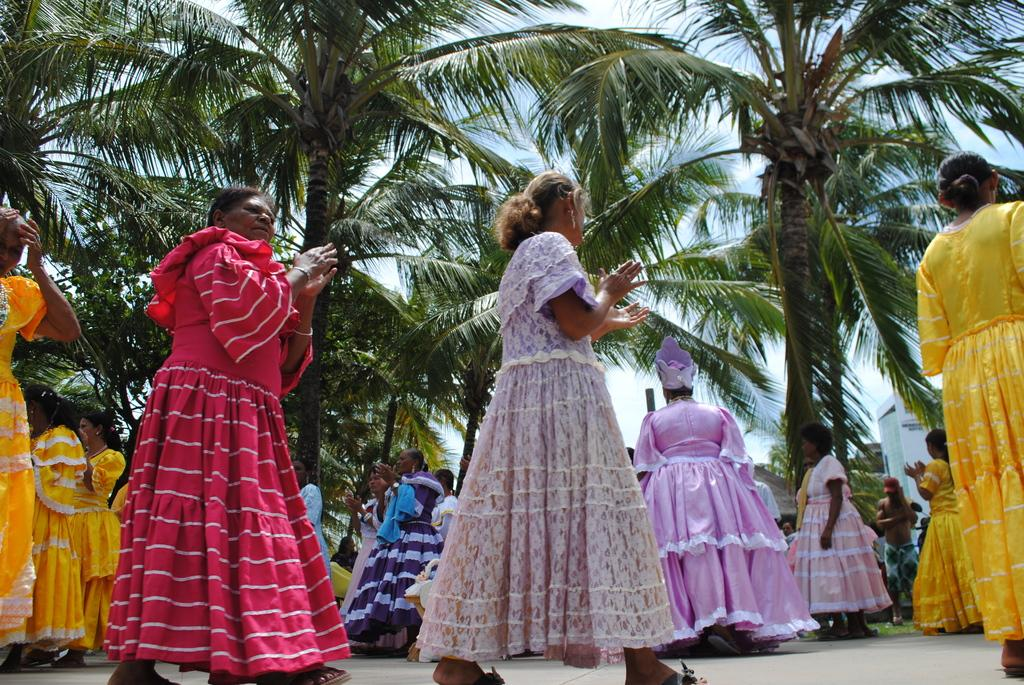Who or what can be seen in the image? There are people in the image. What can be seen in the background of the image? There are trees, at least one building, and the sky visible in the background of the image. What type of porter is carrying luggage in the image? There is no porter carrying luggage in the image; it only features people, trees, buildings, and the sky. 